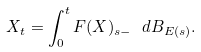<formula> <loc_0><loc_0><loc_500><loc_500>X _ { t } = \int _ { 0 } ^ { t } F ( X ) _ { s - } \text { } d B _ { E ( s ) } .</formula> 